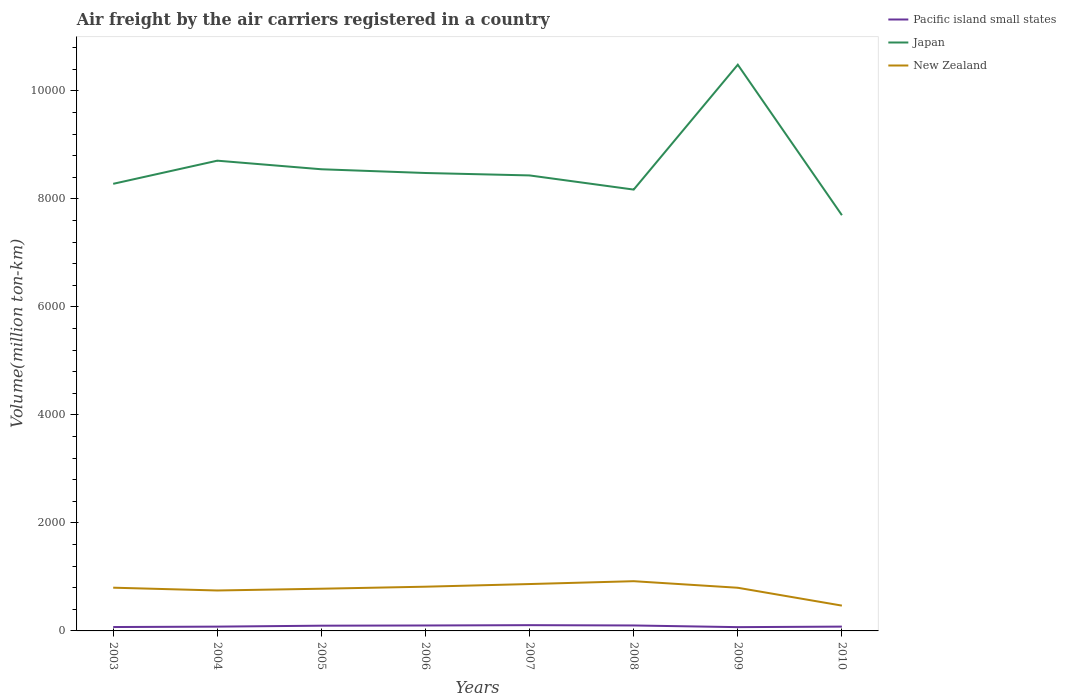Does the line corresponding to Japan intersect with the line corresponding to Pacific island small states?
Provide a short and direct response. No. Across all years, what is the maximum volume of the air carriers in Pacific island small states?
Make the answer very short. 69.89. What is the total volume of the air carriers in New Zealand in the graph?
Your answer should be compact. -52.71. What is the difference between the highest and the second highest volume of the air carriers in Japan?
Offer a terse response. 2786.87. What is the difference between the highest and the lowest volume of the air carriers in Pacific island small states?
Provide a succinct answer. 4. Is the volume of the air carriers in Japan strictly greater than the volume of the air carriers in New Zealand over the years?
Ensure brevity in your answer.  No. How many lines are there?
Your answer should be very brief. 3. Are the values on the major ticks of Y-axis written in scientific E-notation?
Provide a succinct answer. No. Does the graph contain grids?
Provide a short and direct response. No. Where does the legend appear in the graph?
Your response must be concise. Top right. What is the title of the graph?
Your response must be concise. Air freight by the air carriers registered in a country. Does "El Salvador" appear as one of the legend labels in the graph?
Provide a succinct answer. No. What is the label or title of the Y-axis?
Provide a succinct answer. Volume(million ton-km). What is the Volume(million ton-km) of Pacific island small states in 2003?
Your answer should be compact. 71.97. What is the Volume(million ton-km) of Japan in 2003?
Make the answer very short. 8279.58. What is the Volume(million ton-km) in New Zealand in 2003?
Offer a very short reply. 800.52. What is the Volume(million ton-km) of Pacific island small states in 2004?
Your answer should be compact. 79.5. What is the Volume(million ton-km) of Japan in 2004?
Ensure brevity in your answer.  8708.24. What is the Volume(million ton-km) in New Zealand in 2004?
Offer a terse response. 748.83. What is the Volume(million ton-km) in Pacific island small states in 2005?
Ensure brevity in your answer.  96.83. What is the Volume(million ton-km) of Japan in 2005?
Keep it short and to the point. 8549.24. What is the Volume(million ton-km) of New Zealand in 2005?
Your answer should be very brief. 781.47. What is the Volume(million ton-km) in Pacific island small states in 2006?
Offer a very short reply. 100.7. What is the Volume(million ton-km) of Japan in 2006?
Your response must be concise. 8480.02. What is the Volume(million ton-km) in New Zealand in 2006?
Keep it short and to the point. 819. What is the Volume(million ton-km) of Pacific island small states in 2007?
Offer a terse response. 106.72. What is the Volume(million ton-km) of Japan in 2007?
Give a very brief answer. 8435.07. What is the Volume(million ton-km) in New Zealand in 2007?
Keep it short and to the point. 868.14. What is the Volume(million ton-km) of Pacific island small states in 2008?
Your answer should be compact. 100.99. What is the Volume(million ton-km) in Japan in 2008?
Provide a short and direct response. 8172.81. What is the Volume(million ton-km) of New Zealand in 2008?
Keep it short and to the point. 920.85. What is the Volume(million ton-km) of Pacific island small states in 2009?
Provide a short and direct response. 69.89. What is the Volume(million ton-km) of Japan in 2009?
Your answer should be very brief. 1.05e+04. What is the Volume(million ton-km) of New Zealand in 2009?
Offer a terse response. 799.29. What is the Volume(million ton-km) of Pacific island small states in 2010?
Offer a very short reply. 79.81. What is the Volume(million ton-km) of Japan in 2010?
Keep it short and to the point. 7698.8. What is the Volume(million ton-km) in New Zealand in 2010?
Make the answer very short. 468.64. Across all years, what is the maximum Volume(million ton-km) of Pacific island small states?
Provide a succinct answer. 106.72. Across all years, what is the maximum Volume(million ton-km) in Japan?
Your response must be concise. 1.05e+04. Across all years, what is the maximum Volume(million ton-km) in New Zealand?
Offer a very short reply. 920.85. Across all years, what is the minimum Volume(million ton-km) of Pacific island small states?
Provide a short and direct response. 69.89. Across all years, what is the minimum Volume(million ton-km) of Japan?
Your answer should be compact. 7698.8. Across all years, what is the minimum Volume(million ton-km) of New Zealand?
Your response must be concise. 468.64. What is the total Volume(million ton-km) of Pacific island small states in the graph?
Ensure brevity in your answer.  706.42. What is the total Volume(million ton-km) in Japan in the graph?
Ensure brevity in your answer.  6.88e+04. What is the total Volume(million ton-km) of New Zealand in the graph?
Provide a short and direct response. 6206.75. What is the difference between the Volume(million ton-km) in Pacific island small states in 2003 and that in 2004?
Your response must be concise. -7.53. What is the difference between the Volume(million ton-km) of Japan in 2003 and that in 2004?
Offer a terse response. -428.67. What is the difference between the Volume(million ton-km) in New Zealand in 2003 and that in 2004?
Keep it short and to the point. 51.69. What is the difference between the Volume(million ton-km) of Pacific island small states in 2003 and that in 2005?
Provide a succinct answer. -24.85. What is the difference between the Volume(million ton-km) in Japan in 2003 and that in 2005?
Give a very brief answer. -269.67. What is the difference between the Volume(million ton-km) of New Zealand in 2003 and that in 2005?
Ensure brevity in your answer.  19.05. What is the difference between the Volume(million ton-km) in Pacific island small states in 2003 and that in 2006?
Your answer should be very brief. -28.73. What is the difference between the Volume(million ton-km) of Japan in 2003 and that in 2006?
Offer a very short reply. -200.45. What is the difference between the Volume(million ton-km) of New Zealand in 2003 and that in 2006?
Give a very brief answer. -18.48. What is the difference between the Volume(million ton-km) of Pacific island small states in 2003 and that in 2007?
Your answer should be very brief. -34.75. What is the difference between the Volume(million ton-km) of Japan in 2003 and that in 2007?
Provide a short and direct response. -155.49. What is the difference between the Volume(million ton-km) of New Zealand in 2003 and that in 2007?
Provide a succinct answer. -67.62. What is the difference between the Volume(million ton-km) in Pacific island small states in 2003 and that in 2008?
Provide a short and direct response. -29.02. What is the difference between the Volume(million ton-km) in Japan in 2003 and that in 2008?
Keep it short and to the point. 106.77. What is the difference between the Volume(million ton-km) in New Zealand in 2003 and that in 2008?
Provide a succinct answer. -120.32. What is the difference between the Volume(million ton-km) of Pacific island small states in 2003 and that in 2009?
Give a very brief answer. 2.08. What is the difference between the Volume(million ton-km) in Japan in 2003 and that in 2009?
Ensure brevity in your answer.  -2206.09. What is the difference between the Volume(million ton-km) of New Zealand in 2003 and that in 2009?
Your response must be concise. 1.23. What is the difference between the Volume(million ton-km) of Pacific island small states in 2003 and that in 2010?
Give a very brief answer. -7.84. What is the difference between the Volume(million ton-km) in Japan in 2003 and that in 2010?
Your response must be concise. 580.78. What is the difference between the Volume(million ton-km) of New Zealand in 2003 and that in 2010?
Keep it short and to the point. 331.89. What is the difference between the Volume(million ton-km) of Pacific island small states in 2004 and that in 2005?
Provide a succinct answer. -17.32. What is the difference between the Volume(million ton-km) in Japan in 2004 and that in 2005?
Offer a terse response. 159. What is the difference between the Volume(million ton-km) of New Zealand in 2004 and that in 2005?
Keep it short and to the point. -32.64. What is the difference between the Volume(million ton-km) of Pacific island small states in 2004 and that in 2006?
Offer a very short reply. -21.2. What is the difference between the Volume(million ton-km) in Japan in 2004 and that in 2006?
Give a very brief answer. 228.22. What is the difference between the Volume(million ton-km) of New Zealand in 2004 and that in 2006?
Your answer should be very brief. -70.17. What is the difference between the Volume(million ton-km) in Pacific island small states in 2004 and that in 2007?
Give a very brief answer. -27.22. What is the difference between the Volume(million ton-km) in Japan in 2004 and that in 2007?
Provide a succinct answer. 273.18. What is the difference between the Volume(million ton-km) of New Zealand in 2004 and that in 2007?
Your answer should be very brief. -119.31. What is the difference between the Volume(million ton-km) in Pacific island small states in 2004 and that in 2008?
Your answer should be compact. -21.49. What is the difference between the Volume(million ton-km) in Japan in 2004 and that in 2008?
Keep it short and to the point. 535.44. What is the difference between the Volume(million ton-km) of New Zealand in 2004 and that in 2008?
Provide a short and direct response. -172.01. What is the difference between the Volume(million ton-km) in Pacific island small states in 2004 and that in 2009?
Give a very brief answer. 9.61. What is the difference between the Volume(million ton-km) in Japan in 2004 and that in 2009?
Offer a very short reply. -1777.42. What is the difference between the Volume(million ton-km) in New Zealand in 2004 and that in 2009?
Make the answer very short. -50.46. What is the difference between the Volume(million ton-km) of Pacific island small states in 2004 and that in 2010?
Make the answer very short. -0.3. What is the difference between the Volume(million ton-km) of Japan in 2004 and that in 2010?
Keep it short and to the point. 1009.45. What is the difference between the Volume(million ton-km) of New Zealand in 2004 and that in 2010?
Your answer should be compact. 280.19. What is the difference between the Volume(million ton-km) in Pacific island small states in 2005 and that in 2006?
Provide a short and direct response. -3.88. What is the difference between the Volume(million ton-km) of Japan in 2005 and that in 2006?
Keep it short and to the point. 69.22. What is the difference between the Volume(million ton-km) of New Zealand in 2005 and that in 2006?
Offer a very short reply. -37.53. What is the difference between the Volume(million ton-km) of Pacific island small states in 2005 and that in 2007?
Provide a short and direct response. -9.9. What is the difference between the Volume(million ton-km) in Japan in 2005 and that in 2007?
Provide a succinct answer. 114.17. What is the difference between the Volume(million ton-km) in New Zealand in 2005 and that in 2007?
Your answer should be compact. -86.67. What is the difference between the Volume(million ton-km) in Pacific island small states in 2005 and that in 2008?
Your answer should be very brief. -4.17. What is the difference between the Volume(million ton-km) in Japan in 2005 and that in 2008?
Provide a succinct answer. 376.43. What is the difference between the Volume(million ton-km) in New Zealand in 2005 and that in 2008?
Your response must be concise. -139.38. What is the difference between the Volume(million ton-km) in Pacific island small states in 2005 and that in 2009?
Provide a succinct answer. 26.93. What is the difference between the Volume(million ton-km) in Japan in 2005 and that in 2009?
Give a very brief answer. -1936.42. What is the difference between the Volume(million ton-km) in New Zealand in 2005 and that in 2009?
Provide a short and direct response. -17.83. What is the difference between the Volume(million ton-km) of Pacific island small states in 2005 and that in 2010?
Give a very brief answer. 17.02. What is the difference between the Volume(million ton-km) of Japan in 2005 and that in 2010?
Make the answer very short. 850.44. What is the difference between the Volume(million ton-km) in New Zealand in 2005 and that in 2010?
Keep it short and to the point. 312.83. What is the difference between the Volume(million ton-km) of Pacific island small states in 2006 and that in 2007?
Provide a succinct answer. -6.02. What is the difference between the Volume(million ton-km) in Japan in 2006 and that in 2007?
Your response must be concise. 44.95. What is the difference between the Volume(million ton-km) in New Zealand in 2006 and that in 2007?
Ensure brevity in your answer.  -49.14. What is the difference between the Volume(million ton-km) in Pacific island small states in 2006 and that in 2008?
Make the answer very short. -0.29. What is the difference between the Volume(million ton-km) in Japan in 2006 and that in 2008?
Your response must be concise. 307.22. What is the difference between the Volume(million ton-km) in New Zealand in 2006 and that in 2008?
Offer a terse response. -101.85. What is the difference between the Volume(million ton-km) of Pacific island small states in 2006 and that in 2009?
Make the answer very short. 30.81. What is the difference between the Volume(million ton-km) of Japan in 2006 and that in 2009?
Offer a very short reply. -2005.64. What is the difference between the Volume(million ton-km) of New Zealand in 2006 and that in 2009?
Offer a terse response. 19.7. What is the difference between the Volume(million ton-km) in Pacific island small states in 2006 and that in 2010?
Offer a very short reply. 20.9. What is the difference between the Volume(million ton-km) of Japan in 2006 and that in 2010?
Keep it short and to the point. 781.23. What is the difference between the Volume(million ton-km) in New Zealand in 2006 and that in 2010?
Keep it short and to the point. 350.36. What is the difference between the Volume(million ton-km) of Pacific island small states in 2007 and that in 2008?
Ensure brevity in your answer.  5.73. What is the difference between the Volume(million ton-km) in Japan in 2007 and that in 2008?
Your response must be concise. 262.26. What is the difference between the Volume(million ton-km) in New Zealand in 2007 and that in 2008?
Make the answer very short. -52.71. What is the difference between the Volume(million ton-km) of Pacific island small states in 2007 and that in 2009?
Give a very brief answer. 36.83. What is the difference between the Volume(million ton-km) of Japan in 2007 and that in 2009?
Make the answer very short. -2050.6. What is the difference between the Volume(million ton-km) in New Zealand in 2007 and that in 2009?
Your answer should be very brief. 68.84. What is the difference between the Volume(million ton-km) of Pacific island small states in 2007 and that in 2010?
Give a very brief answer. 26.92. What is the difference between the Volume(million ton-km) in Japan in 2007 and that in 2010?
Your answer should be very brief. 736.27. What is the difference between the Volume(million ton-km) of New Zealand in 2007 and that in 2010?
Your answer should be compact. 399.5. What is the difference between the Volume(million ton-km) in Pacific island small states in 2008 and that in 2009?
Provide a short and direct response. 31.1. What is the difference between the Volume(million ton-km) in Japan in 2008 and that in 2009?
Your answer should be very brief. -2312.86. What is the difference between the Volume(million ton-km) of New Zealand in 2008 and that in 2009?
Provide a succinct answer. 121.55. What is the difference between the Volume(million ton-km) of Pacific island small states in 2008 and that in 2010?
Your answer should be compact. 21.19. What is the difference between the Volume(million ton-km) of Japan in 2008 and that in 2010?
Make the answer very short. 474.01. What is the difference between the Volume(million ton-km) in New Zealand in 2008 and that in 2010?
Your response must be concise. 452.21. What is the difference between the Volume(million ton-km) of Pacific island small states in 2009 and that in 2010?
Your response must be concise. -9.92. What is the difference between the Volume(million ton-km) of Japan in 2009 and that in 2010?
Make the answer very short. 2786.87. What is the difference between the Volume(million ton-km) in New Zealand in 2009 and that in 2010?
Provide a short and direct response. 330.66. What is the difference between the Volume(million ton-km) of Pacific island small states in 2003 and the Volume(million ton-km) of Japan in 2004?
Provide a short and direct response. -8636.27. What is the difference between the Volume(million ton-km) of Pacific island small states in 2003 and the Volume(million ton-km) of New Zealand in 2004?
Your response must be concise. -676.86. What is the difference between the Volume(million ton-km) in Japan in 2003 and the Volume(million ton-km) in New Zealand in 2004?
Provide a succinct answer. 7530.74. What is the difference between the Volume(million ton-km) in Pacific island small states in 2003 and the Volume(million ton-km) in Japan in 2005?
Make the answer very short. -8477.27. What is the difference between the Volume(million ton-km) of Pacific island small states in 2003 and the Volume(million ton-km) of New Zealand in 2005?
Make the answer very short. -709.5. What is the difference between the Volume(million ton-km) of Japan in 2003 and the Volume(million ton-km) of New Zealand in 2005?
Provide a succinct answer. 7498.11. What is the difference between the Volume(million ton-km) in Pacific island small states in 2003 and the Volume(million ton-km) in Japan in 2006?
Ensure brevity in your answer.  -8408.05. What is the difference between the Volume(million ton-km) of Pacific island small states in 2003 and the Volume(million ton-km) of New Zealand in 2006?
Provide a short and direct response. -747.03. What is the difference between the Volume(million ton-km) in Japan in 2003 and the Volume(million ton-km) in New Zealand in 2006?
Offer a terse response. 7460.58. What is the difference between the Volume(million ton-km) in Pacific island small states in 2003 and the Volume(million ton-km) in Japan in 2007?
Give a very brief answer. -8363.1. What is the difference between the Volume(million ton-km) of Pacific island small states in 2003 and the Volume(million ton-km) of New Zealand in 2007?
Give a very brief answer. -796.17. What is the difference between the Volume(million ton-km) of Japan in 2003 and the Volume(million ton-km) of New Zealand in 2007?
Offer a terse response. 7411.44. What is the difference between the Volume(million ton-km) of Pacific island small states in 2003 and the Volume(million ton-km) of Japan in 2008?
Provide a succinct answer. -8100.84. What is the difference between the Volume(million ton-km) in Pacific island small states in 2003 and the Volume(million ton-km) in New Zealand in 2008?
Give a very brief answer. -848.88. What is the difference between the Volume(million ton-km) of Japan in 2003 and the Volume(million ton-km) of New Zealand in 2008?
Ensure brevity in your answer.  7358.73. What is the difference between the Volume(million ton-km) in Pacific island small states in 2003 and the Volume(million ton-km) in Japan in 2009?
Offer a very short reply. -1.04e+04. What is the difference between the Volume(million ton-km) in Pacific island small states in 2003 and the Volume(million ton-km) in New Zealand in 2009?
Ensure brevity in your answer.  -727.32. What is the difference between the Volume(million ton-km) in Japan in 2003 and the Volume(million ton-km) in New Zealand in 2009?
Your response must be concise. 7480.28. What is the difference between the Volume(million ton-km) in Pacific island small states in 2003 and the Volume(million ton-km) in Japan in 2010?
Offer a very short reply. -7626.83. What is the difference between the Volume(million ton-km) in Pacific island small states in 2003 and the Volume(million ton-km) in New Zealand in 2010?
Give a very brief answer. -396.67. What is the difference between the Volume(million ton-km) in Japan in 2003 and the Volume(million ton-km) in New Zealand in 2010?
Provide a succinct answer. 7810.94. What is the difference between the Volume(million ton-km) in Pacific island small states in 2004 and the Volume(million ton-km) in Japan in 2005?
Offer a very short reply. -8469.74. What is the difference between the Volume(million ton-km) in Pacific island small states in 2004 and the Volume(million ton-km) in New Zealand in 2005?
Provide a succinct answer. -701.96. What is the difference between the Volume(million ton-km) in Japan in 2004 and the Volume(million ton-km) in New Zealand in 2005?
Your answer should be very brief. 7926.77. What is the difference between the Volume(million ton-km) of Pacific island small states in 2004 and the Volume(million ton-km) of Japan in 2006?
Provide a succinct answer. -8400.52. What is the difference between the Volume(million ton-km) in Pacific island small states in 2004 and the Volume(million ton-km) in New Zealand in 2006?
Offer a very short reply. -739.5. What is the difference between the Volume(million ton-km) of Japan in 2004 and the Volume(million ton-km) of New Zealand in 2006?
Give a very brief answer. 7889.24. What is the difference between the Volume(million ton-km) in Pacific island small states in 2004 and the Volume(million ton-km) in Japan in 2007?
Your answer should be very brief. -8355.56. What is the difference between the Volume(million ton-km) in Pacific island small states in 2004 and the Volume(million ton-km) in New Zealand in 2007?
Make the answer very short. -788.63. What is the difference between the Volume(million ton-km) in Japan in 2004 and the Volume(million ton-km) in New Zealand in 2007?
Give a very brief answer. 7840.1. What is the difference between the Volume(million ton-km) of Pacific island small states in 2004 and the Volume(million ton-km) of Japan in 2008?
Your answer should be compact. -8093.3. What is the difference between the Volume(million ton-km) of Pacific island small states in 2004 and the Volume(million ton-km) of New Zealand in 2008?
Offer a very short reply. -841.34. What is the difference between the Volume(million ton-km) of Japan in 2004 and the Volume(million ton-km) of New Zealand in 2008?
Offer a terse response. 7787.4. What is the difference between the Volume(million ton-km) in Pacific island small states in 2004 and the Volume(million ton-km) in Japan in 2009?
Ensure brevity in your answer.  -1.04e+04. What is the difference between the Volume(million ton-km) in Pacific island small states in 2004 and the Volume(million ton-km) in New Zealand in 2009?
Your answer should be very brief. -719.79. What is the difference between the Volume(million ton-km) in Japan in 2004 and the Volume(million ton-km) in New Zealand in 2009?
Keep it short and to the point. 7908.95. What is the difference between the Volume(million ton-km) of Pacific island small states in 2004 and the Volume(million ton-km) of Japan in 2010?
Offer a very short reply. -7619.29. What is the difference between the Volume(million ton-km) of Pacific island small states in 2004 and the Volume(million ton-km) of New Zealand in 2010?
Your answer should be compact. -389.13. What is the difference between the Volume(million ton-km) of Japan in 2004 and the Volume(million ton-km) of New Zealand in 2010?
Your response must be concise. 8239.61. What is the difference between the Volume(million ton-km) of Pacific island small states in 2005 and the Volume(million ton-km) of Japan in 2006?
Keep it short and to the point. -8383.2. What is the difference between the Volume(million ton-km) of Pacific island small states in 2005 and the Volume(million ton-km) of New Zealand in 2006?
Ensure brevity in your answer.  -722.17. What is the difference between the Volume(million ton-km) in Japan in 2005 and the Volume(million ton-km) in New Zealand in 2006?
Provide a succinct answer. 7730.24. What is the difference between the Volume(million ton-km) in Pacific island small states in 2005 and the Volume(million ton-km) in Japan in 2007?
Offer a very short reply. -8338.24. What is the difference between the Volume(million ton-km) in Pacific island small states in 2005 and the Volume(million ton-km) in New Zealand in 2007?
Ensure brevity in your answer.  -771.32. What is the difference between the Volume(million ton-km) of Japan in 2005 and the Volume(million ton-km) of New Zealand in 2007?
Your answer should be compact. 7681.1. What is the difference between the Volume(million ton-km) in Pacific island small states in 2005 and the Volume(million ton-km) in Japan in 2008?
Give a very brief answer. -8075.98. What is the difference between the Volume(million ton-km) in Pacific island small states in 2005 and the Volume(million ton-km) in New Zealand in 2008?
Your response must be concise. -824.02. What is the difference between the Volume(million ton-km) in Japan in 2005 and the Volume(million ton-km) in New Zealand in 2008?
Your answer should be compact. 7628.39. What is the difference between the Volume(million ton-km) of Pacific island small states in 2005 and the Volume(million ton-km) of Japan in 2009?
Provide a short and direct response. -1.04e+04. What is the difference between the Volume(million ton-km) of Pacific island small states in 2005 and the Volume(million ton-km) of New Zealand in 2009?
Give a very brief answer. -702.47. What is the difference between the Volume(million ton-km) in Japan in 2005 and the Volume(million ton-km) in New Zealand in 2009?
Give a very brief answer. 7749.95. What is the difference between the Volume(million ton-km) of Pacific island small states in 2005 and the Volume(million ton-km) of Japan in 2010?
Your answer should be compact. -7601.97. What is the difference between the Volume(million ton-km) in Pacific island small states in 2005 and the Volume(million ton-km) in New Zealand in 2010?
Ensure brevity in your answer.  -371.81. What is the difference between the Volume(million ton-km) of Japan in 2005 and the Volume(million ton-km) of New Zealand in 2010?
Provide a succinct answer. 8080.6. What is the difference between the Volume(million ton-km) in Pacific island small states in 2006 and the Volume(million ton-km) in Japan in 2007?
Provide a short and direct response. -8334.36. What is the difference between the Volume(million ton-km) of Pacific island small states in 2006 and the Volume(million ton-km) of New Zealand in 2007?
Your response must be concise. -767.43. What is the difference between the Volume(million ton-km) of Japan in 2006 and the Volume(million ton-km) of New Zealand in 2007?
Offer a very short reply. 7611.88. What is the difference between the Volume(million ton-km) in Pacific island small states in 2006 and the Volume(million ton-km) in Japan in 2008?
Offer a terse response. -8072.1. What is the difference between the Volume(million ton-km) of Pacific island small states in 2006 and the Volume(million ton-km) of New Zealand in 2008?
Your answer should be compact. -820.14. What is the difference between the Volume(million ton-km) in Japan in 2006 and the Volume(million ton-km) in New Zealand in 2008?
Offer a terse response. 7559.18. What is the difference between the Volume(million ton-km) in Pacific island small states in 2006 and the Volume(million ton-km) in Japan in 2009?
Offer a very short reply. -1.04e+04. What is the difference between the Volume(million ton-km) in Pacific island small states in 2006 and the Volume(million ton-km) in New Zealand in 2009?
Give a very brief answer. -698.59. What is the difference between the Volume(million ton-km) of Japan in 2006 and the Volume(million ton-km) of New Zealand in 2009?
Provide a short and direct response. 7680.73. What is the difference between the Volume(million ton-km) in Pacific island small states in 2006 and the Volume(million ton-km) in Japan in 2010?
Make the answer very short. -7598.09. What is the difference between the Volume(million ton-km) in Pacific island small states in 2006 and the Volume(million ton-km) in New Zealand in 2010?
Keep it short and to the point. -367.93. What is the difference between the Volume(million ton-km) in Japan in 2006 and the Volume(million ton-km) in New Zealand in 2010?
Give a very brief answer. 8011.39. What is the difference between the Volume(million ton-km) in Pacific island small states in 2007 and the Volume(million ton-km) in Japan in 2008?
Provide a succinct answer. -8066.08. What is the difference between the Volume(million ton-km) of Pacific island small states in 2007 and the Volume(million ton-km) of New Zealand in 2008?
Your answer should be compact. -814.12. What is the difference between the Volume(million ton-km) in Japan in 2007 and the Volume(million ton-km) in New Zealand in 2008?
Give a very brief answer. 7514.22. What is the difference between the Volume(million ton-km) in Pacific island small states in 2007 and the Volume(million ton-km) in Japan in 2009?
Keep it short and to the point. -1.04e+04. What is the difference between the Volume(million ton-km) of Pacific island small states in 2007 and the Volume(million ton-km) of New Zealand in 2009?
Make the answer very short. -692.57. What is the difference between the Volume(million ton-km) of Japan in 2007 and the Volume(million ton-km) of New Zealand in 2009?
Keep it short and to the point. 7635.77. What is the difference between the Volume(million ton-km) of Pacific island small states in 2007 and the Volume(million ton-km) of Japan in 2010?
Offer a terse response. -7592.07. What is the difference between the Volume(million ton-km) in Pacific island small states in 2007 and the Volume(million ton-km) in New Zealand in 2010?
Ensure brevity in your answer.  -361.92. What is the difference between the Volume(million ton-km) in Japan in 2007 and the Volume(million ton-km) in New Zealand in 2010?
Ensure brevity in your answer.  7966.43. What is the difference between the Volume(million ton-km) in Pacific island small states in 2008 and the Volume(million ton-km) in Japan in 2009?
Offer a terse response. -1.04e+04. What is the difference between the Volume(million ton-km) in Pacific island small states in 2008 and the Volume(million ton-km) in New Zealand in 2009?
Offer a terse response. -698.3. What is the difference between the Volume(million ton-km) in Japan in 2008 and the Volume(million ton-km) in New Zealand in 2009?
Your answer should be compact. 7373.51. What is the difference between the Volume(million ton-km) in Pacific island small states in 2008 and the Volume(million ton-km) in Japan in 2010?
Offer a very short reply. -7597.8. What is the difference between the Volume(million ton-km) in Pacific island small states in 2008 and the Volume(million ton-km) in New Zealand in 2010?
Offer a very short reply. -367.64. What is the difference between the Volume(million ton-km) in Japan in 2008 and the Volume(million ton-km) in New Zealand in 2010?
Give a very brief answer. 7704.17. What is the difference between the Volume(million ton-km) of Pacific island small states in 2009 and the Volume(million ton-km) of Japan in 2010?
Offer a terse response. -7628.91. What is the difference between the Volume(million ton-km) of Pacific island small states in 2009 and the Volume(million ton-km) of New Zealand in 2010?
Give a very brief answer. -398.75. What is the difference between the Volume(million ton-km) in Japan in 2009 and the Volume(million ton-km) in New Zealand in 2010?
Give a very brief answer. 1.00e+04. What is the average Volume(million ton-km) in Pacific island small states per year?
Offer a terse response. 88.3. What is the average Volume(million ton-km) in Japan per year?
Provide a short and direct response. 8601.18. What is the average Volume(million ton-km) of New Zealand per year?
Ensure brevity in your answer.  775.84. In the year 2003, what is the difference between the Volume(million ton-km) in Pacific island small states and Volume(million ton-km) in Japan?
Keep it short and to the point. -8207.6. In the year 2003, what is the difference between the Volume(million ton-km) in Pacific island small states and Volume(million ton-km) in New Zealand?
Offer a terse response. -728.55. In the year 2003, what is the difference between the Volume(million ton-km) in Japan and Volume(million ton-km) in New Zealand?
Offer a very short reply. 7479.05. In the year 2004, what is the difference between the Volume(million ton-km) of Pacific island small states and Volume(million ton-km) of Japan?
Give a very brief answer. -8628.74. In the year 2004, what is the difference between the Volume(million ton-km) of Pacific island small states and Volume(million ton-km) of New Zealand?
Give a very brief answer. -669.33. In the year 2004, what is the difference between the Volume(million ton-km) of Japan and Volume(million ton-km) of New Zealand?
Ensure brevity in your answer.  7959.41. In the year 2005, what is the difference between the Volume(million ton-km) of Pacific island small states and Volume(million ton-km) of Japan?
Keep it short and to the point. -8452.42. In the year 2005, what is the difference between the Volume(million ton-km) of Pacific island small states and Volume(million ton-km) of New Zealand?
Your answer should be compact. -684.64. In the year 2005, what is the difference between the Volume(million ton-km) in Japan and Volume(million ton-km) in New Zealand?
Keep it short and to the point. 7767.77. In the year 2006, what is the difference between the Volume(million ton-km) of Pacific island small states and Volume(million ton-km) of Japan?
Ensure brevity in your answer.  -8379.32. In the year 2006, what is the difference between the Volume(million ton-km) of Pacific island small states and Volume(million ton-km) of New Zealand?
Your answer should be very brief. -718.29. In the year 2006, what is the difference between the Volume(million ton-km) in Japan and Volume(million ton-km) in New Zealand?
Offer a very short reply. 7661.02. In the year 2007, what is the difference between the Volume(million ton-km) of Pacific island small states and Volume(million ton-km) of Japan?
Offer a terse response. -8328.35. In the year 2007, what is the difference between the Volume(million ton-km) of Pacific island small states and Volume(million ton-km) of New Zealand?
Ensure brevity in your answer.  -761.42. In the year 2007, what is the difference between the Volume(million ton-km) in Japan and Volume(million ton-km) in New Zealand?
Give a very brief answer. 7566.93. In the year 2008, what is the difference between the Volume(million ton-km) in Pacific island small states and Volume(million ton-km) in Japan?
Give a very brief answer. -8071.81. In the year 2008, what is the difference between the Volume(million ton-km) in Pacific island small states and Volume(million ton-km) in New Zealand?
Provide a succinct answer. -819.85. In the year 2008, what is the difference between the Volume(million ton-km) in Japan and Volume(million ton-km) in New Zealand?
Keep it short and to the point. 7251.96. In the year 2009, what is the difference between the Volume(million ton-km) of Pacific island small states and Volume(million ton-km) of Japan?
Offer a terse response. -1.04e+04. In the year 2009, what is the difference between the Volume(million ton-km) of Pacific island small states and Volume(million ton-km) of New Zealand?
Keep it short and to the point. -729.4. In the year 2009, what is the difference between the Volume(million ton-km) in Japan and Volume(million ton-km) in New Zealand?
Provide a succinct answer. 9686.37. In the year 2010, what is the difference between the Volume(million ton-km) in Pacific island small states and Volume(million ton-km) in Japan?
Your answer should be very brief. -7618.99. In the year 2010, what is the difference between the Volume(million ton-km) of Pacific island small states and Volume(million ton-km) of New Zealand?
Offer a very short reply. -388.83. In the year 2010, what is the difference between the Volume(million ton-km) in Japan and Volume(million ton-km) in New Zealand?
Provide a short and direct response. 7230.16. What is the ratio of the Volume(million ton-km) of Pacific island small states in 2003 to that in 2004?
Keep it short and to the point. 0.91. What is the ratio of the Volume(million ton-km) of Japan in 2003 to that in 2004?
Give a very brief answer. 0.95. What is the ratio of the Volume(million ton-km) in New Zealand in 2003 to that in 2004?
Ensure brevity in your answer.  1.07. What is the ratio of the Volume(million ton-km) in Pacific island small states in 2003 to that in 2005?
Ensure brevity in your answer.  0.74. What is the ratio of the Volume(million ton-km) of Japan in 2003 to that in 2005?
Make the answer very short. 0.97. What is the ratio of the Volume(million ton-km) in New Zealand in 2003 to that in 2005?
Your response must be concise. 1.02. What is the ratio of the Volume(million ton-km) in Pacific island small states in 2003 to that in 2006?
Provide a succinct answer. 0.71. What is the ratio of the Volume(million ton-km) of Japan in 2003 to that in 2006?
Make the answer very short. 0.98. What is the ratio of the Volume(million ton-km) in New Zealand in 2003 to that in 2006?
Your answer should be very brief. 0.98. What is the ratio of the Volume(million ton-km) in Pacific island small states in 2003 to that in 2007?
Provide a short and direct response. 0.67. What is the ratio of the Volume(million ton-km) of Japan in 2003 to that in 2007?
Keep it short and to the point. 0.98. What is the ratio of the Volume(million ton-km) in New Zealand in 2003 to that in 2007?
Keep it short and to the point. 0.92. What is the ratio of the Volume(million ton-km) of Pacific island small states in 2003 to that in 2008?
Your response must be concise. 0.71. What is the ratio of the Volume(million ton-km) of Japan in 2003 to that in 2008?
Your answer should be very brief. 1.01. What is the ratio of the Volume(million ton-km) in New Zealand in 2003 to that in 2008?
Make the answer very short. 0.87. What is the ratio of the Volume(million ton-km) in Pacific island small states in 2003 to that in 2009?
Offer a terse response. 1.03. What is the ratio of the Volume(million ton-km) of Japan in 2003 to that in 2009?
Make the answer very short. 0.79. What is the ratio of the Volume(million ton-km) of Pacific island small states in 2003 to that in 2010?
Your answer should be compact. 0.9. What is the ratio of the Volume(million ton-km) of Japan in 2003 to that in 2010?
Keep it short and to the point. 1.08. What is the ratio of the Volume(million ton-km) in New Zealand in 2003 to that in 2010?
Ensure brevity in your answer.  1.71. What is the ratio of the Volume(million ton-km) of Pacific island small states in 2004 to that in 2005?
Your answer should be very brief. 0.82. What is the ratio of the Volume(million ton-km) in Japan in 2004 to that in 2005?
Ensure brevity in your answer.  1.02. What is the ratio of the Volume(million ton-km) of New Zealand in 2004 to that in 2005?
Make the answer very short. 0.96. What is the ratio of the Volume(million ton-km) of Pacific island small states in 2004 to that in 2006?
Provide a short and direct response. 0.79. What is the ratio of the Volume(million ton-km) in Japan in 2004 to that in 2006?
Provide a succinct answer. 1.03. What is the ratio of the Volume(million ton-km) in New Zealand in 2004 to that in 2006?
Provide a succinct answer. 0.91. What is the ratio of the Volume(million ton-km) in Pacific island small states in 2004 to that in 2007?
Provide a short and direct response. 0.74. What is the ratio of the Volume(million ton-km) of Japan in 2004 to that in 2007?
Offer a terse response. 1.03. What is the ratio of the Volume(million ton-km) in New Zealand in 2004 to that in 2007?
Make the answer very short. 0.86. What is the ratio of the Volume(million ton-km) in Pacific island small states in 2004 to that in 2008?
Make the answer very short. 0.79. What is the ratio of the Volume(million ton-km) of Japan in 2004 to that in 2008?
Provide a short and direct response. 1.07. What is the ratio of the Volume(million ton-km) of New Zealand in 2004 to that in 2008?
Your answer should be compact. 0.81. What is the ratio of the Volume(million ton-km) in Pacific island small states in 2004 to that in 2009?
Your response must be concise. 1.14. What is the ratio of the Volume(million ton-km) in Japan in 2004 to that in 2009?
Your answer should be compact. 0.83. What is the ratio of the Volume(million ton-km) of New Zealand in 2004 to that in 2009?
Provide a succinct answer. 0.94. What is the ratio of the Volume(million ton-km) of Pacific island small states in 2004 to that in 2010?
Offer a terse response. 1. What is the ratio of the Volume(million ton-km) of Japan in 2004 to that in 2010?
Your answer should be very brief. 1.13. What is the ratio of the Volume(million ton-km) in New Zealand in 2004 to that in 2010?
Provide a succinct answer. 1.6. What is the ratio of the Volume(million ton-km) of Pacific island small states in 2005 to that in 2006?
Make the answer very short. 0.96. What is the ratio of the Volume(million ton-km) in Japan in 2005 to that in 2006?
Offer a terse response. 1.01. What is the ratio of the Volume(million ton-km) of New Zealand in 2005 to that in 2006?
Your answer should be compact. 0.95. What is the ratio of the Volume(million ton-km) in Pacific island small states in 2005 to that in 2007?
Make the answer very short. 0.91. What is the ratio of the Volume(million ton-km) in Japan in 2005 to that in 2007?
Keep it short and to the point. 1.01. What is the ratio of the Volume(million ton-km) of New Zealand in 2005 to that in 2007?
Provide a short and direct response. 0.9. What is the ratio of the Volume(million ton-km) of Pacific island small states in 2005 to that in 2008?
Your response must be concise. 0.96. What is the ratio of the Volume(million ton-km) of Japan in 2005 to that in 2008?
Your response must be concise. 1.05. What is the ratio of the Volume(million ton-km) in New Zealand in 2005 to that in 2008?
Your response must be concise. 0.85. What is the ratio of the Volume(million ton-km) of Pacific island small states in 2005 to that in 2009?
Provide a short and direct response. 1.39. What is the ratio of the Volume(million ton-km) of Japan in 2005 to that in 2009?
Give a very brief answer. 0.82. What is the ratio of the Volume(million ton-km) of New Zealand in 2005 to that in 2009?
Give a very brief answer. 0.98. What is the ratio of the Volume(million ton-km) of Pacific island small states in 2005 to that in 2010?
Give a very brief answer. 1.21. What is the ratio of the Volume(million ton-km) of Japan in 2005 to that in 2010?
Provide a short and direct response. 1.11. What is the ratio of the Volume(million ton-km) of New Zealand in 2005 to that in 2010?
Provide a succinct answer. 1.67. What is the ratio of the Volume(million ton-km) in Pacific island small states in 2006 to that in 2007?
Give a very brief answer. 0.94. What is the ratio of the Volume(million ton-km) of New Zealand in 2006 to that in 2007?
Make the answer very short. 0.94. What is the ratio of the Volume(million ton-km) of Japan in 2006 to that in 2008?
Keep it short and to the point. 1.04. What is the ratio of the Volume(million ton-km) of New Zealand in 2006 to that in 2008?
Ensure brevity in your answer.  0.89. What is the ratio of the Volume(million ton-km) in Pacific island small states in 2006 to that in 2009?
Keep it short and to the point. 1.44. What is the ratio of the Volume(million ton-km) of Japan in 2006 to that in 2009?
Your response must be concise. 0.81. What is the ratio of the Volume(million ton-km) of New Zealand in 2006 to that in 2009?
Provide a short and direct response. 1.02. What is the ratio of the Volume(million ton-km) of Pacific island small states in 2006 to that in 2010?
Offer a very short reply. 1.26. What is the ratio of the Volume(million ton-km) of Japan in 2006 to that in 2010?
Give a very brief answer. 1.1. What is the ratio of the Volume(million ton-km) of New Zealand in 2006 to that in 2010?
Make the answer very short. 1.75. What is the ratio of the Volume(million ton-km) in Pacific island small states in 2007 to that in 2008?
Give a very brief answer. 1.06. What is the ratio of the Volume(million ton-km) in Japan in 2007 to that in 2008?
Provide a short and direct response. 1.03. What is the ratio of the Volume(million ton-km) of New Zealand in 2007 to that in 2008?
Keep it short and to the point. 0.94. What is the ratio of the Volume(million ton-km) in Pacific island small states in 2007 to that in 2009?
Provide a short and direct response. 1.53. What is the ratio of the Volume(million ton-km) of Japan in 2007 to that in 2009?
Give a very brief answer. 0.8. What is the ratio of the Volume(million ton-km) of New Zealand in 2007 to that in 2009?
Your answer should be very brief. 1.09. What is the ratio of the Volume(million ton-km) in Pacific island small states in 2007 to that in 2010?
Ensure brevity in your answer.  1.34. What is the ratio of the Volume(million ton-km) of Japan in 2007 to that in 2010?
Your answer should be compact. 1.1. What is the ratio of the Volume(million ton-km) in New Zealand in 2007 to that in 2010?
Your answer should be very brief. 1.85. What is the ratio of the Volume(million ton-km) in Pacific island small states in 2008 to that in 2009?
Offer a very short reply. 1.45. What is the ratio of the Volume(million ton-km) of Japan in 2008 to that in 2009?
Ensure brevity in your answer.  0.78. What is the ratio of the Volume(million ton-km) of New Zealand in 2008 to that in 2009?
Offer a very short reply. 1.15. What is the ratio of the Volume(million ton-km) of Pacific island small states in 2008 to that in 2010?
Offer a terse response. 1.27. What is the ratio of the Volume(million ton-km) of Japan in 2008 to that in 2010?
Your answer should be compact. 1.06. What is the ratio of the Volume(million ton-km) in New Zealand in 2008 to that in 2010?
Your response must be concise. 1.96. What is the ratio of the Volume(million ton-km) of Pacific island small states in 2009 to that in 2010?
Your answer should be compact. 0.88. What is the ratio of the Volume(million ton-km) in Japan in 2009 to that in 2010?
Your answer should be very brief. 1.36. What is the ratio of the Volume(million ton-km) of New Zealand in 2009 to that in 2010?
Keep it short and to the point. 1.71. What is the difference between the highest and the second highest Volume(million ton-km) of Pacific island small states?
Provide a succinct answer. 5.73. What is the difference between the highest and the second highest Volume(million ton-km) of Japan?
Keep it short and to the point. 1777.42. What is the difference between the highest and the second highest Volume(million ton-km) of New Zealand?
Your answer should be very brief. 52.71. What is the difference between the highest and the lowest Volume(million ton-km) in Pacific island small states?
Your answer should be compact. 36.83. What is the difference between the highest and the lowest Volume(million ton-km) of Japan?
Keep it short and to the point. 2786.87. What is the difference between the highest and the lowest Volume(million ton-km) in New Zealand?
Provide a succinct answer. 452.21. 